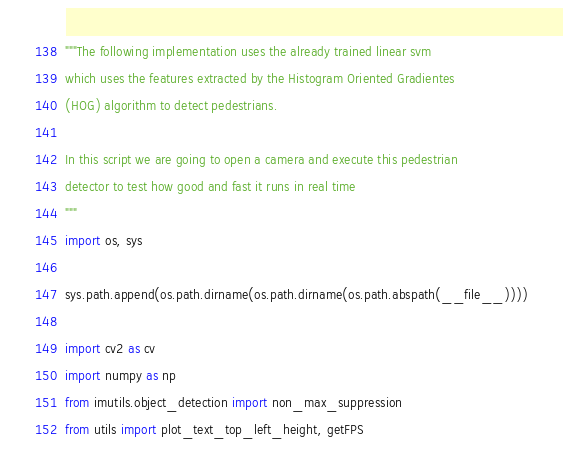<code> <loc_0><loc_0><loc_500><loc_500><_Python_>"""The following implementation uses the already trained linear svm
which uses the features extracted by the Histogram Oriented Gradientes
(HOG) algorithm to detect pedestrians.

In this script we are going to open a camera and execute this pedestrian
detector to test how good and fast it runs in real time
"""
import os, sys

sys.path.append(os.path.dirname(os.path.dirname(os.path.abspath(__file__))))

import cv2 as cv
import numpy as np
from imutils.object_detection import non_max_suppression
from utils import plot_text_top_left_height, getFPS
</code> 